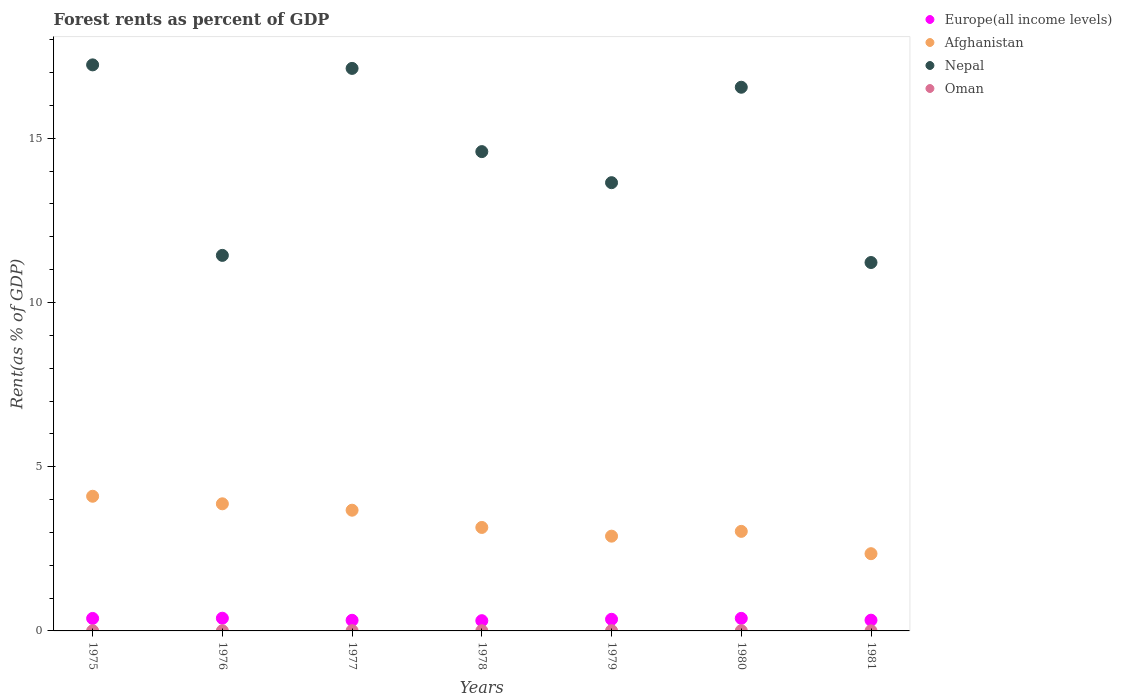How many different coloured dotlines are there?
Give a very brief answer. 4. What is the forest rent in Europe(all income levels) in 1979?
Your answer should be compact. 0.35. Across all years, what is the maximum forest rent in Afghanistan?
Ensure brevity in your answer.  4.1. Across all years, what is the minimum forest rent in Nepal?
Make the answer very short. 11.22. What is the total forest rent in Europe(all income levels) in the graph?
Your answer should be compact. 2.47. What is the difference between the forest rent in Oman in 1975 and that in 1978?
Provide a succinct answer. -0. What is the difference between the forest rent in Nepal in 1978 and the forest rent in Europe(all income levels) in 1980?
Provide a short and direct response. 14.21. What is the average forest rent in Nepal per year?
Make the answer very short. 14.54. In the year 1978, what is the difference between the forest rent in Oman and forest rent in Afghanistan?
Keep it short and to the point. -3.15. What is the ratio of the forest rent in Nepal in 1979 to that in 1980?
Ensure brevity in your answer.  0.82. Is the difference between the forest rent in Oman in 1977 and 1981 greater than the difference between the forest rent in Afghanistan in 1977 and 1981?
Offer a terse response. No. What is the difference between the highest and the second highest forest rent in Europe(all income levels)?
Your answer should be compact. 0. What is the difference between the highest and the lowest forest rent in Europe(all income levels)?
Keep it short and to the point. 0.07. In how many years, is the forest rent in Europe(all income levels) greater than the average forest rent in Europe(all income levels) taken over all years?
Your response must be concise. 4. Is the sum of the forest rent in Oman in 1975 and 1977 greater than the maximum forest rent in Afghanistan across all years?
Offer a terse response. No. Is it the case that in every year, the sum of the forest rent in Oman and forest rent in Europe(all income levels)  is greater than the sum of forest rent in Nepal and forest rent in Afghanistan?
Make the answer very short. No. Is the forest rent in Nepal strictly greater than the forest rent in Europe(all income levels) over the years?
Your response must be concise. Yes. Is the forest rent in Afghanistan strictly less than the forest rent in Europe(all income levels) over the years?
Your response must be concise. No. How many years are there in the graph?
Offer a terse response. 7. What is the difference between two consecutive major ticks on the Y-axis?
Provide a short and direct response. 5. Are the values on the major ticks of Y-axis written in scientific E-notation?
Your answer should be compact. No. Does the graph contain any zero values?
Give a very brief answer. No. Does the graph contain grids?
Keep it short and to the point. No. How many legend labels are there?
Your answer should be compact. 4. What is the title of the graph?
Your response must be concise. Forest rents as percent of GDP. Does "Kosovo" appear as one of the legend labels in the graph?
Ensure brevity in your answer.  No. What is the label or title of the X-axis?
Your answer should be compact. Years. What is the label or title of the Y-axis?
Keep it short and to the point. Rent(as % of GDP). What is the Rent(as % of GDP) in Europe(all income levels) in 1975?
Offer a very short reply. 0.38. What is the Rent(as % of GDP) in Afghanistan in 1975?
Give a very brief answer. 4.1. What is the Rent(as % of GDP) of Nepal in 1975?
Your answer should be very brief. 17.23. What is the Rent(as % of GDP) of Oman in 1975?
Give a very brief answer. 0. What is the Rent(as % of GDP) in Europe(all income levels) in 1976?
Make the answer very short. 0.39. What is the Rent(as % of GDP) in Afghanistan in 1976?
Give a very brief answer. 3.87. What is the Rent(as % of GDP) in Nepal in 1976?
Provide a short and direct response. 11.43. What is the Rent(as % of GDP) in Oman in 1976?
Provide a short and direct response. 0. What is the Rent(as % of GDP) in Europe(all income levels) in 1977?
Your answer should be very brief. 0.32. What is the Rent(as % of GDP) in Afghanistan in 1977?
Your answer should be very brief. 3.68. What is the Rent(as % of GDP) in Nepal in 1977?
Provide a succinct answer. 17.13. What is the Rent(as % of GDP) in Oman in 1977?
Your response must be concise. 0.01. What is the Rent(as % of GDP) of Europe(all income levels) in 1978?
Offer a terse response. 0.31. What is the Rent(as % of GDP) of Afghanistan in 1978?
Ensure brevity in your answer.  3.15. What is the Rent(as % of GDP) of Nepal in 1978?
Give a very brief answer. 14.59. What is the Rent(as % of GDP) in Oman in 1978?
Provide a short and direct response. 0.01. What is the Rent(as % of GDP) of Europe(all income levels) in 1979?
Offer a very short reply. 0.35. What is the Rent(as % of GDP) of Afghanistan in 1979?
Keep it short and to the point. 2.89. What is the Rent(as % of GDP) in Nepal in 1979?
Your response must be concise. 13.65. What is the Rent(as % of GDP) of Oman in 1979?
Your answer should be very brief. 0.01. What is the Rent(as % of GDP) in Europe(all income levels) in 1980?
Keep it short and to the point. 0.38. What is the Rent(as % of GDP) of Afghanistan in 1980?
Your answer should be compact. 3.03. What is the Rent(as % of GDP) of Nepal in 1980?
Ensure brevity in your answer.  16.55. What is the Rent(as % of GDP) in Oman in 1980?
Offer a very short reply. 0.01. What is the Rent(as % of GDP) in Europe(all income levels) in 1981?
Your answer should be very brief. 0.33. What is the Rent(as % of GDP) of Afghanistan in 1981?
Give a very brief answer. 2.35. What is the Rent(as % of GDP) in Nepal in 1981?
Your answer should be compact. 11.22. What is the Rent(as % of GDP) in Oman in 1981?
Your response must be concise. 0. Across all years, what is the maximum Rent(as % of GDP) of Europe(all income levels)?
Your answer should be very brief. 0.39. Across all years, what is the maximum Rent(as % of GDP) of Afghanistan?
Your answer should be very brief. 4.1. Across all years, what is the maximum Rent(as % of GDP) of Nepal?
Provide a short and direct response. 17.23. Across all years, what is the maximum Rent(as % of GDP) in Oman?
Keep it short and to the point. 0.01. Across all years, what is the minimum Rent(as % of GDP) of Europe(all income levels)?
Provide a succinct answer. 0.31. Across all years, what is the minimum Rent(as % of GDP) in Afghanistan?
Your response must be concise. 2.35. Across all years, what is the minimum Rent(as % of GDP) in Nepal?
Your answer should be very brief. 11.22. Across all years, what is the minimum Rent(as % of GDP) of Oman?
Make the answer very short. 0. What is the total Rent(as % of GDP) of Europe(all income levels) in the graph?
Offer a terse response. 2.47. What is the total Rent(as % of GDP) in Afghanistan in the graph?
Give a very brief answer. 23.06. What is the total Rent(as % of GDP) of Nepal in the graph?
Your answer should be very brief. 101.81. What is the total Rent(as % of GDP) in Oman in the graph?
Provide a short and direct response. 0.04. What is the difference between the Rent(as % of GDP) in Europe(all income levels) in 1975 and that in 1976?
Offer a terse response. -0.01. What is the difference between the Rent(as % of GDP) of Afghanistan in 1975 and that in 1976?
Offer a very short reply. 0.23. What is the difference between the Rent(as % of GDP) in Nepal in 1975 and that in 1976?
Make the answer very short. 5.8. What is the difference between the Rent(as % of GDP) in Oman in 1975 and that in 1976?
Ensure brevity in your answer.  -0. What is the difference between the Rent(as % of GDP) of Europe(all income levels) in 1975 and that in 1977?
Offer a very short reply. 0.06. What is the difference between the Rent(as % of GDP) of Afghanistan in 1975 and that in 1977?
Ensure brevity in your answer.  0.42. What is the difference between the Rent(as % of GDP) in Nepal in 1975 and that in 1977?
Provide a succinct answer. 0.11. What is the difference between the Rent(as % of GDP) of Oman in 1975 and that in 1977?
Offer a terse response. -0. What is the difference between the Rent(as % of GDP) in Europe(all income levels) in 1975 and that in 1978?
Give a very brief answer. 0.07. What is the difference between the Rent(as % of GDP) in Afghanistan in 1975 and that in 1978?
Offer a very short reply. 0.95. What is the difference between the Rent(as % of GDP) in Nepal in 1975 and that in 1978?
Provide a short and direct response. 2.64. What is the difference between the Rent(as % of GDP) of Oman in 1975 and that in 1978?
Make the answer very short. -0. What is the difference between the Rent(as % of GDP) in Europe(all income levels) in 1975 and that in 1979?
Make the answer very short. 0.03. What is the difference between the Rent(as % of GDP) of Afghanistan in 1975 and that in 1979?
Offer a terse response. 1.22. What is the difference between the Rent(as % of GDP) of Nepal in 1975 and that in 1979?
Make the answer very short. 3.59. What is the difference between the Rent(as % of GDP) in Oman in 1975 and that in 1979?
Your response must be concise. -0. What is the difference between the Rent(as % of GDP) of Europe(all income levels) in 1975 and that in 1980?
Offer a very short reply. -0. What is the difference between the Rent(as % of GDP) of Afghanistan in 1975 and that in 1980?
Give a very brief answer. 1.07. What is the difference between the Rent(as % of GDP) of Nepal in 1975 and that in 1980?
Your response must be concise. 0.68. What is the difference between the Rent(as % of GDP) in Oman in 1975 and that in 1980?
Make the answer very short. -0. What is the difference between the Rent(as % of GDP) in Europe(all income levels) in 1975 and that in 1981?
Provide a short and direct response. 0.05. What is the difference between the Rent(as % of GDP) of Afghanistan in 1975 and that in 1981?
Your answer should be very brief. 1.75. What is the difference between the Rent(as % of GDP) in Nepal in 1975 and that in 1981?
Your answer should be very brief. 6.02. What is the difference between the Rent(as % of GDP) of Oman in 1975 and that in 1981?
Provide a succinct answer. 0. What is the difference between the Rent(as % of GDP) in Europe(all income levels) in 1976 and that in 1977?
Make the answer very short. 0.06. What is the difference between the Rent(as % of GDP) in Afghanistan in 1976 and that in 1977?
Keep it short and to the point. 0.19. What is the difference between the Rent(as % of GDP) of Nepal in 1976 and that in 1977?
Ensure brevity in your answer.  -5.69. What is the difference between the Rent(as % of GDP) of Oman in 1976 and that in 1977?
Your answer should be very brief. -0. What is the difference between the Rent(as % of GDP) of Europe(all income levels) in 1976 and that in 1978?
Offer a very short reply. 0.07. What is the difference between the Rent(as % of GDP) in Afghanistan in 1976 and that in 1978?
Offer a very short reply. 0.72. What is the difference between the Rent(as % of GDP) of Nepal in 1976 and that in 1978?
Ensure brevity in your answer.  -3.16. What is the difference between the Rent(as % of GDP) in Oman in 1976 and that in 1978?
Offer a very short reply. -0. What is the difference between the Rent(as % of GDP) of Europe(all income levels) in 1976 and that in 1979?
Make the answer very short. 0.03. What is the difference between the Rent(as % of GDP) in Afghanistan in 1976 and that in 1979?
Your answer should be compact. 0.99. What is the difference between the Rent(as % of GDP) of Nepal in 1976 and that in 1979?
Keep it short and to the point. -2.21. What is the difference between the Rent(as % of GDP) of Oman in 1976 and that in 1979?
Give a very brief answer. -0. What is the difference between the Rent(as % of GDP) of Europe(all income levels) in 1976 and that in 1980?
Provide a succinct answer. 0. What is the difference between the Rent(as % of GDP) in Afghanistan in 1976 and that in 1980?
Ensure brevity in your answer.  0.84. What is the difference between the Rent(as % of GDP) of Nepal in 1976 and that in 1980?
Your answer should be very brief. -5.12. What is the difference between the Rent(as % of GDP) in Oman in 1976 and that in 1980?
Your response must be concise. -0. What is the difference between the Rent(as % of GDP) of Europe(all income levels) in 1976 and that in 1981?
Your answer should be compact. 0.06. What is the difference between the Rent(as % of GDP) of Afghanistan in 1976 and that in 1981?
Give a very brief answer. 1.52. What is the difference between the Rent(as % of GDP) in Nepal in 1976 and that in 1981?
Make the answer very short. 0.22. What is the difference between the Rent(as % of GDP) of Oman in 1976 and that in 1981?
Ensure brevity in your answer.  0. What is the difference between the Rent(as % of GDP) of Europe(all income levels) in 1977 and that in 1978?
Keep it short and to the point. 0.01. What is the difference between the Rent(as % of GDP) of Afghanistan in 1977 and that in 1978?
Your answer should be compact. 0.52. What is the difference between the Rent(as % of GDP) of Nepal in 1977 and that in 1978?
Your answer should be compact. 2.53. What is the difference between the Rent(as % of GDP) in Oman in 1977 and that in 1978?
Give a very brief answer. 0. What is the difference between the Rent(as % of GDP) in Europe(all income levels) in 1977 and that in 1979?
Give a very brief answer. -0.03. What is the difference between the Rent(as % of GDP) in Afghanistan in 1977 and that in 1979?
Offer a terse response. 0.79. What is the difference between the Rent(as % of GDP) of Nepal in 1977 and that in 1979?
Provide a short and direct response. 3.48. What is the difference between the Rent(as % of GDP) in Oman in 1977 and that in 1979?
Offer a terse response. 0. What is the difference between the Rent(as % of GDP) in Europe(all income levels) in 1977 and that in 1980?
Offer a terse response. -0.06. What is the difference between the Rent(as % of GDP) in Afghanistan in 1977 and that in 1980?
Give a very brief answer. 0.64. What is the difference between the Rent(as % of GDP) in Nepal in 1977 and that in 1980?
Keep it short and to the point. 0.57. What is the difference between the Rent(as % of GDP) in Oman in 1977 and that in 1980?
Offer a very short reply. 0. What is the difference between the Rent(as % of GDP) in Europe(all income levels) in 1977 and that in 1981?
Offer a terse response. -0. What is the difference between the Rent(as % of GDP) in Afghanistan in 1977 and that in 1981?
Provide a succinct answer. 1.32. What is the difference between the Rent(as % of GDP) of Nepal in 1977 and that in 1981?
Your response must be concise. 5.91. What is the difference between the Rent(as % of GDP) of Oman in 1977 and that in 1981?
Provide a succinct answer. 0. What is the difference between the Rent(as % of GDP) in Europe(all income levels) in 1978 and that in 1979?
Your answer should be very brief. -0.04. What is the difference between the Rent(as % of GDP) of Afghanistan in 1978 and that in 1979?
Ensure brevity in your answer.  0.27. What is the difference between the Rent(as % of GDP) in Nepal in 1978 and that in 1979?
Your response must be concise. 0.95. What is the difference between the Rent(as % of GDP) in Oman in 1978 and that in 1979?
Offer a terse response. -0. What is the difference between the Rent(as % of GDP) of Europe(all income levels) in 1978 and that in 1980?
Ensure brevity in your answer.  -0.07. What is the difference between the Rent(as % of GDP) of Afghanistan in 1978 and that in 1980?
Your answer should be very brief. 0.12. What is the difference between the Rent(as % of GDP) in Nepal in 1978 and that in 1980?
Your answer should be very brief. -1.96. What is the difference between the Rent(as % of GDP) of Oman in 1978 and that in 1980?
Make the answer very short. -0. What is the difference between the Rent(as % of GDP) in Europe(all income levels) in 1978 and that in 1981?
Keep it short and to the point. -0.02. What is the difference between the Rent(as % of GDP) of Afghanistan in 1978 and that in 1981?
Ensure brevity in your answer.  0.8. What is the difference between the Rent(as % of GDP) of Nepal in 1978 and that in 1981?
Offer a very short reply. 3.38. What is the difference between the Rent(as % of GDP) of Oman in 1978 and that in 1981?
Provide a short and direct response. 0. What is the difference between the Rent(as % of GDP) of Europe(all income levels) in 1979 and that in 1980?
Make the answer very short. -0.03. What is the difference between the Rent(as % of GDP) in Afghanistan in 1979 and that in 1980?
Offer a terse response. -0.15. What is the difference between the Rent(as % of GDP) in Nepal in 1979 and that in 1980?
Your answer should be very brief. -2.91. What is the difference between the Rent(as % of GDP) in Oman in 1979 and that in 1980?
Keep it short and to the point. 0. What is the difference between the Rent(as % of GDP) in Europe(all income levels) in 1979 and that in 1981?
Provide a short and direct response. 0.03. What is the difference between the Rent(as % of GDP) in Afghanistan in 1979 and that in 1981?
Your answer should be compact. 0.53. What is the difference between the Rent(as % of GDP) of Nepal in 1979 and that in 1981?
Give a very brief answer. 2.43. What is the difference between the Rent(as % of GDP) in Oman in 1979 and that in 1981?
Provide a short and direct response. 0. What is the difference between the Rent(as % of GDP) in Europe(all income levels) in 1980 and that in 1981?
Give a very brief answer. 0.06. What is the difference between the Rent(as % of GDP) of Afghanistan in 1980 and that in 1981?
Your response must be concise. 0.68. What is the difference between the Rent(as % of GDP) in Nepal in 1980 and that in 1981?
Your answer should be compact. 5.34. What is the difference between the Rent(as % of GDP) of Oman in 1980 and that in 1981?
Provide a succinct answer. 0. What is the difference between the Rent(as % of GDP) of Europe(all income levels) in 1975 and the Rent(as % of GDP) of Afghanistan in 1976?
Your answer should be very brief. -3.49. What is the difference between the Rent(as % of GDP) in Europe(all income levels) in 1975 and the Rent(as % of GDP) in Nepal in 1976?
Your response must be concise. -11.05. What is the difference between the Rent(as % of GDP) of Europe(all income levels) in 1975 and the Rent(as % of GDP) of Oman in 1976?
Make the answer very short. 0.38. What is the difference between the Rent(as % of GDP) of Afghanistan in 1975 and the Rent(as % of GDP) of Nepal in 1976?
Your response must be concise. -7.33. What is the difference between the Rent(as % of GDP) of Afghanistan in 1975 and the Rent(as % of GDP) of Oman in 1976?
Your answer should be compact. 4.1. What is the difference between the Rent(as % of GDP) of Nepal in 1975 and the Rent(as % of GDP) of Oman in 1976?
Give a very brief answer. 17.23. What is the difference between the Rent(as % of GDP) of Europe(all income levels) in 1975 and the Rent(as % of GDP) of Afghanistan in 1977?
Offer a very short reply. -3.3. What is the difference between the Rent(as % of GDP) of Europe(all income levels) in 1975 and the Rent(as % of GDP) of Nepal in 1977?
Offer a very short reply. -16.75. What is the difference between the Rent(as % of GDP) of Europe(all income levels) in 1975 and the Rent(as % of GDP) of Oman in 1977?
Make the answer very short. 0.37. What is the difference between the Rent(as % of GDP) in Afghanistan in 1975 and the Rent(as % of GDP) in Nepal in 1977?
Provide a short and direct response. -13.03. What is the difference between the Rent(as % of GDP) in Afghanistan in 1975 and the Rent(as % of GDP) in Oman in 1977?
Provide a short and direct response. 4.09. What is the difference between the Rent(as % of GDP) in Nepal in 1975 and the Rent(as % of GDP) in Oman in 1977?
Make the answer very short. 17.23. What is the difference between the Rent(as % of GDP) of Europe(all income levels) in 1975 and the Rent(as % of GDP) of Afghanistan in 1978?
Your answer should be very brief. -2.77. What is the difference between the Rent(as % of GDP) in Europe(all income levels) in 1975 and the Rent(as % of GDP) in Nepal in 1978?
Give a very brief answer. -14.21. What is the difference between the Rent(as % of GDP) of Europe(all income levels) in 1975 and the Rent(as % of GDP) of Oman in 1978?
Your answer should be compact. 0.37. What is the difference between the Rent(as % of GDP) of Afghanistan in 1975 and the Rent(as % of GDP) of Nepal in 1978?
Your answer should be very brief. -10.49. What is the difference between the Rent(as % of GDP) of Afghanistan in 1975 and the Rent(as % of GDP) of Oman in 1978?
Your response must be concise. 4.09. What is the difference between the Rent(as % of GDP) in Nepal in 1975 and the Rent(as % of GDP) in Oman in 1978?
Ensure brevity in your answer.  17.23. What is the difference between the Rent(as % of GDP) in Europe(all income levels) in 1975 and the Rent(as % of GDP) in Afghanistan in 1979?
Give a very brief answer. -2.5. What is the difference between the Rent(as % of GDP) in Europe(all income levels) in 1975 and the Rent(as % of GDP) in Nepal in 1979?
Give a very brief answer. -13.27. What is the difference between the Rent(as % of GDP) in Europe(all income levels) in 1975 and the Rent(as % of GDP) in Oman in 1979?
Your answer should be very brief. 0.37. What is the difference between the Rent(as % of GDP) in Afghanistan in 1975 and the Rent(as % of GDP) in Nepal in 1979?
Offer a terse response. -9.55. What is the difference between the Rent(as % of GDP) in Afghanistan in 1975 and the Rent(as % of GDP) in Oman in 1979?
Provide a succinct answer. 4.09. What is the difference between the Rent(as % of GDP) in Nepal in 1975 and the Rent(as % of GDP) in Oman in 1979?
Give a very brief answer. 17.23. What is the difference between the Rent(as % of GDP) of Europe(all income levels) in 1975 and the Rent(as % of GDP) of Afghanistan in 1980?
Give a very brief answer. -2.65. What is the difference between the Rent(as % of GDP) in Europe(all income levels) in 1975 and the Rent(as % of GDP) in Nepal in 1980?
Your answer should be very brief. -16.17. What is the difference between the Rent(as % of GDP) of Europe(all income levels) in 1975 and the Rent(as % of GDP) of Oman in 1980?
Keep it short and to the point. 0.37. What is the difference between the Rent(as % of GDP) of Afghanistan in 1975 and the Rent(as % of GDP) of Nepal in 1980?
Provide a short and direct response. -12.45. What is the difference between the Rent(as % of GDP) of Afghanistan in 1975 and the Rent(as % of GDP) of Oman in 1980?
Keep it short and to the point. 4.09. What is the difference between the Rent(as % of GDP) of Nepal in 1975 and the Rent(as % of GDP) of Oman in 1980?
Your answer should be compact. 17.23. What is the difference between the Rent(as % of GDP) of Europe(all income levels) in 1975 and the Rent(as % of GDP) of Afghanistan in 1981?
Your answer should be very brief. -1.97. What is the difference between the Rent(as % of GDP) of Europe(all income levels) in 1975 and the Rent(as % of GDP) of Nepal in 1981?
Your response must be concise. -10.84. What is the difference between the Rent(as % of GDP) of Europe(all income levels) in 1975 and the Rent(as % of GDP) of Oman in 1981?
Offer a terse response. 0.38. What is the difference between the Rent(as % of GDP) of Afghanistan in 1975 and the Rent(as % of GDP) of Nepal in 1981?
Make the answer very short. -7.12. What is the difference between the Rent(as % of GDP) of Afghanistan in 1975 and the Rent(as % of GDP) of Oman in 1981?
Give a very brief answer. 4.1. What is the difference between the Rent(as % of GDP) of Nepal in 1975 and the Rent(as % of GDP) of Oman in 1981?
Keep it short and to the point. 17.23. What is the difference between the Rent(as % of GDP) in Europe(all income levels) in 1976 and the Rent(as % of GDP) in Afghanistan in 1977?
Provide a short and direct response. -3.29. What is the difference between the Rent(as % of GDP) in Europe(all income levels) in 1976 and the Rent(as % of GDP) in Nepal in 1977?
Give a very brief answer. -16.74. What is the difference between the Rent(as % of GDP) in Europe(all income levels) in 1976 and the Rent(as % of GDP) in Oman in 1977?
Your answer should be very brief. 0.38. What is the difference between the Rent(as % of GDP) of Afghanistan in 1976 and the Rent(as % of GDP) of Nepal in 1977?
Offer a very short reply. -13.26. What is the difference between the Rent(as % of GDP) in Afghanistan in 1976 and the Rent(as % of GDP) in Oman in 1977?
Offer a terse response. 3.86. What is the difference between the Rent(as % of GDP) in Nepal in 1976 and the Rent(as % of GDP) in Oman in 1977?
Your response must be concise. 11.43. What is the difference between the Rent(as % of GDP) of Europe(all income levels) in 1976 and the Rent(as % of GDP) of Afghanistan in 1978?
Your response must be concise. -2.76. What is the difference between the Rent(as % of GDP) of Europe(all income levels) in 1976 and the Rent(as % of GDP) of Nepal in 1978?
Make the answer very short. -14.21. What is the difference between the Rent(as % of GDP) of Europe(all income levels) in 1976 and the Rent(as % of GDP) of Oman in 1978?
Make the answer very short. 0.38. What is the difference between the Rent(as % of GDP) in Afghanistan in 1976 and the Rent(as % of GDP) in Nepal in 1978?
Offer a terse response. -10.72. What is the difference between the Rent(as % of GDP) in Afghanistan in 1976 and the Rent(as % of GDP) in Oman in 1978?
Offer a very short reply. 3.86. What is the difference between the Rent(as % of GDP) in Nepal in 1976 and the Rent(as % of GDP) in Oman in 1978?
Your response must be concise. 11.43. What is the difference between the Rent(as % of GDP) of Europe(all income levels) in 1976 and the Rent(as % of GDP) of Afghanistan in 1979?
Your response must be concise. -2.5. What is the difference between the Rent(as % of GDP) in Europe(all income levels) in 1976 and the Rent(as % of GDP) in Nepal in 1979?
Make the answer very short. -13.26. What is the difference between the Rent(as % of GDP) in Europe(all income levels) in 1976 and the Rent(as % of GDP) in Oman in 1979?
Keep it short and to the point. 0.38. What is the difference between the Rent(as % of GDP) in Afghanistan in 1976 and the Rent(as % of GDP) in Nepal in 1979?
Provide a short and direct response. -9.78. What is the difference between the Rent(as % of GDP) in Afghanistan in 1976 and the Rent(as % of GDP) in Oman in 1979?
Your answer should be compact. 3.86. What is the difference between the Rent(as % of GDP) of Nepal in 1976 and the Rent(as % of GDP) of Oman in 1979?
Make the answer very short. 11.43. What is the difference between the Rent(as % of GDP) in Europe(all income levels) in 1976 and the Rent(as % of GDP) in Afghanistan in 1980?
Ensure brevity in your answer.  -2.64. What is the difference between the Rent(as % of GDP) of Europe(all income levels) in 1976 and the Rent(as % of GDP) of Nepal in 1980?
Your response must be concise. -16.17. What is the difference between the Rent(as % of GDP) in Europe(all income levels) in 1976 and the Rent(as % of GDP) in Oman in 1980?
Ensure brevity in your answer.  0.38. What is the difference between the Rent(as % of GDP) of Afghanistan in 1976 and the Rent(as % of GDP) of Nepal in 1980?
Your answer should be compact. -12.68. What is the difference between the Rent(as % of GDP) of Afghanistan in 1976 and the Rent(as % of GDP) of Oman in 1980?
Ensure brevity in your answer.  3.86. What is the difference between the Rent(as % of GDP) in Nepal in 1976 and the Rent(as % of GDP) in Oman in 1980?
Provide a succinct answer. 11.43. What is the difference between the Rent(as % of GDP) in Europe(all income levels) in 1976 and the Rent(as % of GDP) in Afghanistan in 1981?
Your response must be concise. -1.97. What is the difference between the Rent(as % of GDP) of Europe(all income levels) in 1976 and the Rent(as % of GDP) of Nepal in 1981?
Your response must be concise. -10.83. What is the difference between the Rent(as % of GDP) in Europe(all income levels) in 1976 and the Rent(as % of GDP) in Oman in 1981?
Your response must be concise. 0.38. What is the difference between the Rent(as % of GDP) in Afghanistan in 1976 and the Rent(as % of GDP) in Nepal in 1981?
Ensure brevity in your answer.  -7.35. What is the difference between the Rent(as % of GDP) in Afghanistan in 1976 and the Rent(as % of GDP) in Oman in 1981?
Your answer should be very brief. 3.87. What is the difference between the Rent(as % of GDP) of Nepal in 1976 and the Rent(as % of GDP) of Oman in 1981?
Your answer should be compact. 11.43. What is the difference between the Rent(as % of GDP) in Europe(all income levels) in 1977 and the Rent(as % of GDP) in Afghanistan in 1978?
Provide a succinct answer. -2.83. What is the difference between the Rent(as % of GDP) in Europe(all income levels) in 1977 and the Rent(as % of GDP) in Nepal in 1978?
Keep it short and to the point. -14.27. What is the difference between the Rent(as % of GDP) in Europe(all income levels) in 1977 and the Rent(as % of GDP) in Oman in 1978?
Offer a very short reply. 0.32. What is the difference between the Rent(as % of GDP) of Afghanistan in 1977 and the Rent(as % of GDP) of Nepal in 1978?
Offer a terse response. -10.92. What is the difference between the Rent(as % of GDP) in Afghanistan in 1977 and the Rent(as % of GDP) in Oman in 1978?
Make the answer very short. 3.67. What is the difference between the Rent(as % of GDP) in Nepal in 1977 and the Rent(as % of GDP) in Oman in 1978?
Your answer should be compact. 17.12. What is the difference between the Rent(as % of GDP) in Europe(all income levels) in 1977 and the Rent(as % of GDP) in Afghanistan in 1979?
Offer a terse response. -2.56. What is the difference between the Rent(as % of GDP) in Europe(all income levels) in 1977 and the Rent(as % of GDP) in Nepal in 1979?
Provide a succinct answer. -13.32. What is the difference between the Rent(as % of GDP) in Europe(all income levels) in 1977 and the Rent(as % of GDP) in Oman in 1979?
Keep it short and to the point. 0.32. What is the difference between the Rent(as % of GDP) in Afghanistan in 1977 and the Rent(as % of GDP) in Nepal in 1979?
Provide a short and direct response. -9.97. What is the difference between the Rent(as % of GDP) in Afghanistan in 1977 and the Rent(as % of GDP) in Oman in 1979?
Provide a short and direct response. 3.67. What is the difference between the Rent(as % of GDP) of Nepal in 1977 and the Rent(as % of GDP) of Oman in 1979?
Your answer should be very brief. 17.12. What is the difference between the Rent(as % of GDP) in Europe(all income levels) in 1977 and the Rent(as % of GDP) in Afghanistan in 1980?
Give a very brief answer. -2.71. What is the difference between the Rent(as % of GDP) in Europe(all income levels) in 1977 and the Rent(as % of GDP) in Nepal in 1980?
Ensure brevity in your answer.  -16.23. What is the difference between the Rent(as % of GDP) of Europe(all income levels) in 1977 and the Rent(as % of GDP) of Oman in 1980?
Ensure brevity in your answer.  0.32. What is the difference between the Rent(as % of GDP) of Afghanistan in 1977 and the Rent(as % of GDP) of Nepal in 1980?
Your answer should be compact. -12.88. What is the difference between the Rent(as % of GDP) in Afghanistan in 1977 and the Rent(as % of GDP) in Oman in 1980?
Provide a short and direct response. 3.67. What is the difference between the Rent(as % of GDP) of Nepal in 1977 and the Rent(as % of GDP) of Oman in 1980?
Ensure brevity in your answer.  17.12. What is the difference between the Rent(as % of GDP) in Europe(all income levels) in 1977 and the Rent(as % of GDP) in Afghanistan in 1981?
Keep it short and to the point. -2.03. What is the difference between the Rent(as % of GDP) in Europe(all income levels) in 1977 and the Rent(as % of GDP) in Nepal in 1981?
Your response must be concise. -10.89. What is the difference between the Rent(as % of GDP) of Europe(all income levels) in 1977 and the Rent(as % of GDP) of Oman in 1981?
Offer a terse response. 0.32. What is the difference between the Rent(as % of GDP) in Afghanistan in 1977 and the Rent(as % of GDP) in Nepal in 1981?
Keep it short and to the point. -7.54. What is the difference between the Rent(as % of GDP) of Afghanistan in 1977 and the Rent(as % of GDP) of Oman in 1981?
Your answer should be very brief. 3.67. What is the difference between the Rent(as % of GDP) in Nepal in 1977 and the Rent(as % of GDP) in Oman in 1981?
Your answer should be very brief. 17.12. What is the difference between the Rent(as % of GDP) in Europe(all income levels) in 1978 and the Rent(as % of GDP) in Afghanistan in 1979?
Your answer should be very brief. -2.57. What is the difference between the Rent(as % of GDP) in Europe(all income levels) in 1978 and the Rent(as % of GDP) in Nepal in 1979?
Provide a succinct answer. -13.34. What is the difference between the Rent(as % of GDP) of Europe(all income levels) in 1978 and the Rent(as % of GDP) of Oman in 1979?
Keep it short and to the point. 0.3. What is the difference between the Rent(as % of GDP) in Afghanistan in 1978 and the Rent(as % of GDP) in Nepal in 1979?
Make the answer very short. -10.5. What is the difference between the Rent(as % of GDP) in Afghanistan in 1978 and the Rent(as % of GDP) in Oman in 1979?
Offer a very short reply. 3.14. What is the difference between the Rent(as % of GDP) in Nepal in 1978 and the Rent(as % of GDP) in Oman in 1979?
Your answer should be very brief. 14.59. What is the difference between the Rent(as % of GDP) in Europe(all income levels) in 1978 and the Rent(as % of GDP) in Afghanistan in 1980?
Your answer should be compact. -2.72. What is the difference between the Rent(as % of GDP) of Europe(all income levels) in 1978 and the Rent(as % of GDP) of Nepal in 1980?
Your answer should be compact. -16.24. What is the difference between the Rent(as % of GDP) in Europe(all income levels) in 1978 and the Rent(as % of GDP) in Oman in 1980?
Keep it short and to the point. 0.31. What is the difference between the Rent(as % of GDP) in Afghanistan in 1978 and the Rent(as % of GDP) in Nepal in 1980?
Provide a short and direct response. -13.4. What is the difference between the Rent(as % of GDP) in Afghanistan in 1978 and the Rent(as % of GDP) in Oman in 1980?
Keep it short and to the point. 3.15. What is the difference between the Rent(as % of GDP) in Nepal in 1978 and the Rent(as % of GDP) in Oman in 1980?
Your response must be concise. 14.59. What is the difference between the Rent(as % of GDP) of Europe(all income levels) in 1978 and the Rent(as % of GDP) of Afghanistan in 1981?
Provide a short and direct response. -2.04. What is the difference between the Rent(as % of GDP) of Europe(all income levels) in 1978 and the Rent(as % of GDP) of Nepal in 1981?
Your response must be concise. -10.91. What is the difference between the Rent(as % of GDP) of Europe(all income levels) in 1978 and the Rent(as % of GDP) of Oman in 1981?
Offer a terse response. 0.31. What is the difference between the Rent(as % of GDP) of Afghanistan in 1978 and the Rent(as % of GDP) of Nepal in 1981?
Your answer should be compact. -8.07. What is the difference between the Rent(as % of GDP) in Afghanistan in 1978 and the Rent(as % of GDP) in Oman in 1981?
Keep it short and to the point. 3.15. What is the difference between the Rent(as % of GDP) in Nepal in 1978 and the Rent(as % of GDP) in Oman in 1981?
Ensure brevity in your answer.  14.59. What is the difference between the Rent(as % of GDP) of Europe(all income levels) in 1979 and the Rent(as % of GDP) of Afghanistan in 1980?
Ensure brevity in your answer.  -2.68. What is the difference between the Rent(as % of GDP) in Europe(all income levels) in 1979 and the Rent(as % of GDP) in Nepal in 1980?
Offer a very short reply. -16.2. What is the difference between the Rent(as % of GDP) of Europe(all income levels) in 1979 and the Rent(as % of GDP) of Oman in 1980?
Offer a terse response. 0.35. What is the difference between the Rent(as % of GDP) of Afghanistan in 1979 and the Rent(as % of GDP) of Nepal in 1980?
Offer a very short reply. -13.67. What is the difference between the Rent(as % of GDP) in Afghanistan in 1979 and the Rent(as % of GDP) in Oman in 1980?
Give a very brief answer. 2.88. What is the difference between the Rent(as % of GDP) in Nepal in 1979 and the Rent(as % of GDP) in Oman in 1980?
Give a very brief answer. 13.64. What is the difference between the Rent(as % of GDP) of Europe(all income levels) in 1979 and the Rent(as % of GDP) of Afghanistan in 1981?
Offer a very short reply. -2. What is the difference between the Rent(as % of GDP) of Europe(all income levels) in 1979 and the Rent(as % of GDP) of Nepal in 1981?
Ensure brevity in your answer.  -10.86. What is the difference between the Rent(as % of GDP) in Europe(all income levels) in 1979 and the Rent(as % of GDP) in Oman in 1981?
Your answer should be compact. 0.35. What is the difference between the Rent(as % of GDP) of Afghanistan in 1979 and the Rent(as % of GDP) of Nepal in 1981?
Keep it short and to the point. -8.33. What is the difference between the Rent(as % of GDP) in Afghanistan in 1979 and the Rent(as % of GDP) in Oman in 1981?
Make the answer very short. 2.88. What is the difference between the Rent(as % of GDP) in Nepal in 1979 and the Rent(as % of GDP) in Oman in 1981?
Offer a terse response. 13.65. What is the difference between the Rent(as % of GDP) in Europe(all income levels) in 1980 and the Rent(as % of GDP) in Afghanistan in 1981?
Provide a succinct answer. -1.97. What is the difference between the Rent(as % of GDP) of Europe(all income levels) in 1980 and the Rent(as % of GDP) of Nepal in 1981?
Make the answer very short. -10.83. What is the difference between the Rent(as % of GDP) in Europe(all income levels) in 1980 and the Rent(as % of GDP) in Oman in 1981?
Keep it short and to the point. 0.38. What is the difference between the Rent(as % of GDP) in Afghanistan in 1980 and the Rent(as % of GDP) in Nepal in 1981?
Your answer should be compact. -8.19. What is the difference between the Rent(as % of GDP) of Afghanistan in 1980 and the Rent(as % of GDP) of Oman in 1981?
Your answer should be very brief. 3.03. What is the difference between the Rent(as % of GDP) in Nepal in 1980 and the Rent(as % of GDP) in Oman in 1981?
Your response must be concise. 16.55. What is the average Rent(as % of GDP) of Europe(all income levels) per year?
Provide a succinct answer. 0.35. What is the average Rent(as % of GDP) of Afghanistan per year?
Your answer should be compact. 3.29. What is the average Rent(as % of GDP) in Nepal per year?
Ensure brevity in your answer.  14.54. What is the average Rent(as % of GDP) of Oman per year?
Your response must be concise. 0.01. In the year 1975, what is the difference between the Rent(as % of GDP) in Europe(all income levels) and Rent(as % of GDP) in Afghanistan?
Offer a terse response. -3.72. In the year 1975, what is the difference between the Rent(as % of GDP) of Europe(all income levels) and Rent(as % of GDP) of Nepal?
Provide a succinct answer. -16.85. In the year 1975, what is the difference between the Rent(as % of GDP) in Europe(all income levels) and Rent(as % of GDP) in Oman?
Provide a short and direct response. 0.38. In the year 1975, what is the difference between the Rent(as % of GDP) of Afghanistan and Rent(as % of GDP) of Nepal?
Give a very brief answer. -13.13. In the year 1975, what is the difference between the Rent(as % of GDP) of Afghanistan and Rent(as % of GDP) of Oman?
Ensure brevity in your answer.  4.1. In the year 1975, what is the difference between the Rent(as % of GDP) of Nepal and Rent(as % of GDP) of Oman?
Make the answer very short. 17.23. In the year 1976, what is the difference between the Rent(as % of GDP) in Europe(all income levels) and Rent(as % of GDP) in Afghanistan?
Give a very brief answer. -3.48. In the year 1976, what is the difference between the Rent(as % of GDP) of Europe(all income levels) and Rent(as % of GDP) of Nepal?
Your answer should be very brief. -11.05. In the year 1976, what is the difference between the Rent(as % of GDP) of Europe(all income levels) and Rent(as % of GDP) of Oman?
Give a very brief answer. 0.38. In the year 1976, what is the difference between the Rent(as % of GDP) of Afghanistan and Rent(as % of GDP) of Nepal?
Offer a very short reply. -7.56. In the year 1976, what is the difference between the Rent(as % of GDP) of Afghanistan and Rent(as % of GDP) of Oman?
Offer a terse response. 3.87. In the year 1976, what is the difference between the Rent(as % of GDP) in Nepal and Rent(as % of GDP) in Oman?
Provide a short and direct response. 11.43. In the year 1977, what is the difference between the Rent(as % of GDP) in Europe(all income levels) and Rent(as % of GDP) in Afghanistan?
Make the answer very short. -3.35. In the year 1977, what is the difference between the Rent(as % of GDP) of Europe(all income levels) and Rent(as % of GDP) of Nepal?
Your answer should be compact. -16.8. In the year 1977, what is the difference between the Rent(as % of GDP) of Europe(all income levels) and Rent(as % of GDP) of Oman?
Offer a terse response. 0.32. In the year 1977, what is the difference between the Rent(as % of GDP) of Afghanistan and Rent(as % of GDP) of Nepal?
Ensure brevity in your answer.  -13.45. In the year 1977, what is the difference between the Rent(as % of GDP) of Afghanistan and Rent(as % of GDP) of Oman?
Offer a very short reply. 3.67. In the year 1977, what is the difference between the Rent(as % of GDP) of Nepal and Rent(as % of GDP) of Oman?
Provide a short and direct response. 17.12. In the year 1978, what is the difference between the Rent(as % of GDP) of Europe(all income levels) and Rent(as % of GDP) of Afghanistan?
Your answer should be very brief. -2.84. In the year 1978, what is the difference between the Rent(as % of GDP) of Europe(all income levels) and Rent(as % of GDP) of Nepal?
Provide a short and direct response. -14.28. In the year 1978, what is the difference between the Rent(as % of GDP) of Europe(all income levels) and Rent(as % of GDP) of Oman?
Keep it short and to the point. 0.31. In the year 1978, what is the difference between the Rent(as % of GDP) of Afghanistan and Rent(as % of GDP) of Nepal?
Keep it short and to the point. -11.44. In the year 1978, what is the difference between the Rent(as % of GDP) of Afghanistan and Rent(as % of GDP) of Oman?
Keep it short and to the point. 3.15. In the year 1978, what is the difference between the Rent(as % of GDP) of Nepal and Rent(as % of GDP) of Oman?
Keep it short and to the point. 14.59. In the year 1979, what is the difference between the Rent(as % of GDP) in Europe(all income levels) and Rent(as % of GDP) in Afghanistan?
Your answer should be very brief. -2.53. In the year 1979, what is the difference between the Rent(as % of GDP) in Europe(all income levels) and Rent(as % of GDP) in Nepal?
Give a very brief answer. -13.29. In the year 1979, what is the difference between the Rent(as % of GDP) in Europe(all income levels) and Rent(as % of GDP) in Oman?
Ensure brevity in your answer.  0.35. In the year 1979, what is the difference between the Rent(as % of GDP) in Afghanistan and Rent(as % of GDP) in Nepal?
Your response must be concise. -10.76. In the year 1979, what is the difference between the Rent(as % of GDP) of Afghanistan and Rent(as % of GDP) of Oman?
Make the answer very short. 2.88. In the year 1979, what is the difference between the Rent(as % of GDP) in Nepal and Rent(as % of GDP) in Oman?
Make the answer very short. 13.64. In the year 1980, what is the difference between the Rent(as % of GDP) in Europe(all income levels) and Rent(as % of GDP) in Afghanistan?
Your response must be concise. -2.65. In the year 1980, what is the difference between the Rent(as % of GDP) of Europe(all income levels) and Rent(as % of GDP) of Nepal?
Keep it short and to the point. -16.17. In the year 1980, what is the difference between the Rent(as % of GDP) of Europe(all income levels) and Rent(as % of GDP) of Oman?
Your answer should be very brief. 0.38. In the year 1980, what is the difference between the Rent(as % of GDP) of Afghanistan and Rent(as % of GDP) of Nepal?
Give a very brief answer. -13.52. In the year 1980, what is the difference between the Rent(as % of GDP) of Afghanistan and Rent(as % of GDP) of Oman?
Offer a very short reply. 3.03. In the year 1980, what is the difference between the Rent(as % of GDP) of Nepal and Rent(as % of GDP) of Oman?
Provide a succinct answer. 16.55. In the year 1981, what is the difference between the Rent(as % of GDP) of Europe(all income levels) and Rent(as % of GDP) of Afghanistan?
Provide a succinct answer. -2.02. In the year 1981, what is the difference between the Rent(as % of GDP) of Europe(all income levels) and Rent(as % of GDP) of Nepal?
Keep it short and to the point. -10.89. In the year 1981, what is the difference between the Rent(as % of GDP) in Europe(all income levels) and Rent(as % of GDP) in Oman?
Keep it short and to the point. 0.32. In the year 1981, what is the difference between the Rent(as % of GDP) in Afghanistan and Rent(as % of GDP) in Nepal?
Offer a terse response. -8.87. In the year 1981, what is the difference between the Rent(as % of GDP) of Afghanistan and Rent(as % of GDP) of Oman?
Your answer should be compact. 2.35. In the year 1981, what is the difference between the Rent(as % of GDP) in Nepal and Rent(as % of GDP) in Oman?
Ensure brevity in your answer.  11.21. What is the ratio of the Rent(as % of GDP) of Europe(all income levels) in 1975 to that in 1976?
Offer a very short reply. 0.98. What is the ratio of the Rent(as % of GDP) of Afghanistan in 1975 to that in 1976?
Ensure brevity in your answer.  1.06. What is the ratio of the Rent(as % of GDP) of Nepal in 1975 to that in 1976?
Offer a very short reply. 1.51. What is the ratio of the Rent(as % of GDP) in Oman in 1975 to that in 1976?
Give a very brief answer. 0.9. What is the ratio of the Rent(as % of GDP) in Europe(all income levels) in 1975 to that in 1977?
Offer a terse response. 1.18. What is the ratio of the Rent(as % of GDP) of Afghanistan in 1975 to that in 1977?
Provide a succinct answer. 1.12. What is the ratio of the Rent(as % of GDP) in Oman in 1975 to that in 1977?
Provide a succinct answer. 0.58. What is the ratio of the Rent(as % of GDP) in Europe(all income levels) in 1975 to that in 1978?
Offer a very short reply. 1.22. What is the ratio of the Rent(as % of GDP) in Afghanistan in 1975 to that in 1978?
Ensure brevity in your answer.  1.3. What is the ratio of the Rent(as % of GDP) in Nepal in 1975 to that in 1978?
Provide a succinct answer. 1.18. What is the ratio of the Rent(as % of GDP) of Oman in 1975 to that in 1978?
Offer a terse response. 0.77. What is the ratio of the Rent(as % of GDP) in Europe(all income levels) in 1975 to that in 1979?
Give a very brief answer. 1.07. What is the ratio of the Rent(as % of GDP) in Afghanistan in 1975 to that in 1979?
Keep it short and to the point. 1.42. What is the ratio of the Rent(as % of GDP) of Nepal in 1975 to that in 1979?
Provide a succinct answer. 1.26. What is the ratio of the Rent(as % of GDP) of Oman in 1975 to that in 1979?
Give a very brief answer. 0.61. What is the ratio of the Rent(as % of GDP) in Europe(all income levels) in 1975 to that in 1980?
Provide a short and direct response. 0.99. What is the ratio of the Rent(as % of GDP) of Afghanistan in 1975 to that in 1980?
Keep it short and to the point. 1.35. What is the ratio of the Rent(as % of GDP) of Nepal in 1975 to that in 1980?
Make the answer very short. 1.04. What is the ratio of the Rent(as % of GDP) in Oman in 1975 to that in 1980?
Provide a succinct answer. 0.74. What is the ratio of the Rent(as % of GDP) of Europe(all income levels) in 1975 to that in 1981?
Your response must be concise. 1.16. What is the ratio of the Rent(as % of GDP) of Afghanistan in 1975 to that in 1981?
Make the answer very short. 1.74. What is the ratio of the Rent(as % of GDP) of Nepal in 1975 to that in 1981?
Your answer should be very brief. 1.54. What is the ratio of the Rent(as % of GDP) in Oman in 1975 to that in 1981?
Offer a very short reply. 1.66. What is the ratio of the Rent(as % of GDP) in Europe(all income levels) in 1976 to that in 1977?
Keep it short and to the point. 1.19. What is the ratio of the Rent(as % of GDP) in Afghanistan in 1976 to that in 1977?
Offer a very short reply. 1.05. What is the ratio of the Rent(as % of GDP) in Nepal in 1976 to that in 1977?
Ensure brevity in your answer.  0.67. What is the ratio of the Rent(as % of GDP) in Oman in 1976 to that in 1977?
Offer a very short reply. 0.65. What is the ratio of the Rent(as % of GDP) of Europe(all income levels) in 1976 to that in 1978?
Your answer should be very brief. 1.24. What is the ratio of the Rent(as % of GDP) of Afghanistan in 1976 to that in 1978?
Provide a succinct answer. 1.23. What is the ratio of the Rent(as % of GDP) of Nepal in 1976 to that in 1978?
Offer a terse response. 0.78. What is the ratio of the Rent(as % of GDP) in Oman in 1976 to that in 1978?
Provide a succinct answer. 0.85. What is the ratio of the Rent(as % of GDP) of Europe(all income levels) in 1976 to that in 1979?
Keep it short and to the point. 1.09. What is the ratio of the Rent(as % of GDP) in Afghanistan in 1976 to that in 1979?
Your answer should be compact. 1.34. What is the ratio of the Rent(as % of GDP) of Nepal in 1976 to that in 1979?
Make the answer very short. 0.84. What is the ratio of the Rent(as % of GDP) in Oman in 1976 to that in 1979?
Give a very brief answer. 0.68. What is the ratio of the Rent(as % of GDP) in Europe(all income levels) in 1976 to that in 1980?
Ensure brevity in your answer.  1.01. What is the ratio of the Rent(as % of GDP) of Afghanistan in 1976 to that in 1980?
Offer a terse response. 1.28. What is the ratio of the Rent(as % of GDP) in Nepal in 1976 to that in 1980?
Ensure brevity in your answer.  0.69. What is the ratio of the Rent(as % of GDP) in Oman in 1976 to that in 1980?
Offer a very short reply. 0.83. What is the ratio of the Rent(as % of GDP) in Europe(all income levels) in 1976 to that in 1981?
Offer a very short reply. 1.18. What is the ratio of the Rent(as % of GDP) in Afghanistan in 1976 to that in 1981?
Offer a terse response. 1.65. What is the ratio of the Rent(as % of GDP) in Nepal in 1976 to that in 1981?
Ensure brevity in your answer.  1.02. What is the ratio of the Rent(as % of GDP) in Oman in 1976 to that in 1981?
Offer a terse response. 1.85. What is the ratio of the Rent(as % of GDP) of Europe(all income levels) in 1977 to that in 1978?
Keep it short and to the point. 1.04. What is the ratio of the Rent(as % of GDP) in Afghanistan in 1977 to that in 1978?
Offer a very short reply. 1.17. What is the ratio of the Rent(as % of GDP) of Nepal in 1977 to that in 1978?
Give a very brief answer. 1.17. What is the ratio of the Rent(as % of GDP) of Oman in 1977 to that in 1978?
Your answer should be very brief. 1.31. What is the ratio of the Rent(as % of GDP) of Europe(all income levels) in 1977 to that in 1979?
Make the answer very short. 0.91. What is the ratio of the Rent(as % of GDP) of Afghanistan in 1977 to that in 1979?
Make the answer very short. 1.27. What is the ratio of the Rent(as % of GDP) of Nepal in 1977 to that in 1979?
Make the answer very short. 1.25. What is the ratio of the Rent(as % of GDP) in Oman in 1977 to that in 1979?
Your response must be concise. 1.05. What is the ratio of the Rent(as % of GDP) of Europe(all income levels) in 1977 to that in 1980?
Your answer should be compact. 0.85. What is the ratio of the Rent(as % of GDP) of Afghanistan in 1977 to that in 1980?
Ensure brevity in your answer.  1.21. What is the ratio of the Rent(as % of GDP) in Nepal in 1977 to that in 1980?
Provide a short and direct response. 1.03. What is the ratio of the Rent(as % of GDP) in Oman in 1977 to that in 1980?
Ensure brevity in your answer.  1.28. What is the ratio of the Rent(as % of GDP) in Afghanistan in 1977 to that in 1981?
Offer a terse response. 1.56. What is the ratio of the Rent(as % of GDP) in Nepal in 1977 to that in 1981?
Offer a very short reply. 1.53. What is the ratio of the Rent(as % of GDP) of Oman in 1977 to that in 1981?
Provide a succinct answer. 2.85. What is the ratio of the Rent(as % of GDP) of Europe(all income levels) in 1978 to that in 1979?
Give a very brief answer. 0.88. What is the ratio of the Rent(as % of GDP) in Afghanistan in 1978 to that in 1979?
Provide a succinct answer. 1.09. What is the ratio of the Rent(as % of GDP) of Nepal in 1978 to that in 1979?
Offer a terse response. 1.07. What is the ratio of the Rent(as % of GDP) in Oman in 1978 to that in 1979?
Make the answer very short. 0.8. What is the ratio of the Rent(as % of GDP) in Europe(all income levels) in 1978 to that in 1980?
Your answer should be very brief. 0.82. What is the ratio of the Rent(as % of GDP) of Afghanistan in 1978 to that in 1980?
Give a very brief answer. 1.04. What is the ratio of the Rent(as % of GDP) of Nepal in 1978 to that in 1980?
Ensure brevity in your answer.  0.88. What is the ratio of the Rent(as % of GDP) in Oman in 1978 to that in 1980?
Offer a very short reply. 0.97. What is the ratio of the Rent(as % of GDP) of Europe(all income levels) in 1978 to that in 1981?
Ensure brevity in your answer.  0.95. What is the ratio of the Rent(as % of GDP) of Afghanistan in 1978 to that in 1981?
Offer a terse response. 1.34. What is the ratio of the Rent(as % of GDP) of Nepal in 1978 to that in 1981?
Offer a very short reply. 1.3. What is the ratio of the Rent(as % of GDP) in Oman in 1978 to that in 1981?
Make the answer very short. 2.17. What is the ratio of the Rent(as % of GDP) in Europe(all income levels) in 1979 to that in 1980?
Give a very brief answer. 0.93. What is the ratio of the Rent(as % of GDP) of Afghanistan in 1979 to that in 1980?
Provide a succinct answer. 0.95. What is the ratio of the Rent(as % of GDP) in Nepal in 1979 to that in 1980?
Your answer should be very brief. 0.82. What is the ratio of the Rent(as % of GDP) of Oman in 1979 to that in 1980?
Offer a terse response. 1.21. What is the ratio of the Rent(as % of GDP) of Europe(all income levels) in 1979 to that in 1981?
Make the answer very short. 1.08. What is the ratio of the Rent(as % of GDP) in Afghanistan in 1979 to that in 1981?
Give a very brief answer. 1.23. What is the ratio of the Rent(as % of GDP) in Nepal in 1979 to that in 1981?
Ensure brevity in your answer.  1.22. What is the ratio of the Rent(as % of GDP) in Oman in 1979 to that in 1981?
Make the answer very short. 2.7. What is the ratio of the Rent(as % of GDP) in Europe(all income levels) in 1980 to that in 1981?
Provide a succinct answer. 1.17. What is the ratio of the Rent(as % of GDP) in Afghanistan in 1980 to that in 1981?
Your response must be concise. 1.29. What is the ratio of the Rent(as % of GDP) in Nepal in 1980 to that in 1981?
Make the answer very short. 1.48. What is the ratio of the Rent(as % of GDP) in Oman in 1980 to that in 1981?
Your answer should be very brief. 2.23. What is the difference between the highest and the second highest Rent(as % of GDP) of Europe(all income levels)?
Keep it short and to the point. 0. What is the difference between the highest and the second highest Rent(as % of GDP) in Afghanistan?
Keep it short and to the point. 0.23. What is the difference between the highest and the second highest Rent(as % of GDP) of Nepal?
Make the answer very short. 0.11. What is the difference between the highest and the second highest Rent(as % of GDP) of Oman?
Offer a very short reply. 0. What is the difference between the highest and the lowest Rent(as % of GDP) of Europe(all income levels)?
Your answer should be very brief. 0.07. What is the difference between the highest and the lowest Rent(as % of GDP) of Afghanistan?
Your answer should be very brief. 1.75. What is the difference between the highest and the lowest Rent(as % of GDP) of Nepal?
Make the answer very short. 6.02. What is the difference between the highest and the lowest Rent(as % of GDP) in Oman?
Offer a very short reply. 0. 